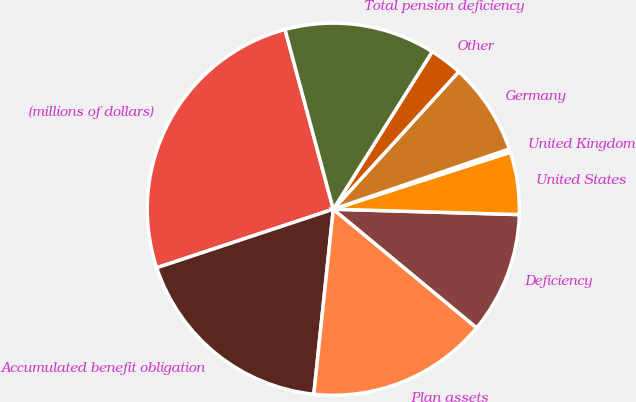Convert chart. <chart><loc_0><loc_0><loc_500><loc_500><pie_chart><fcel>(millions of dollars)<fcel>Accumulated benefit obligation<fcel>Plan assets<fcel>Deficiency<fcel>United States<fcel>United Kingdom<fcel>Germany<fcel>Other<fcel>Total pension deficiency<nl><fcel>25.92%<fcel>18.23%<fcel>15.67%<fcel>10.54%<fcel>5.42%<fcel>0.29%<fcel>7.98%<fcel>2.85%<fcel>13.1%<nl></chart> 